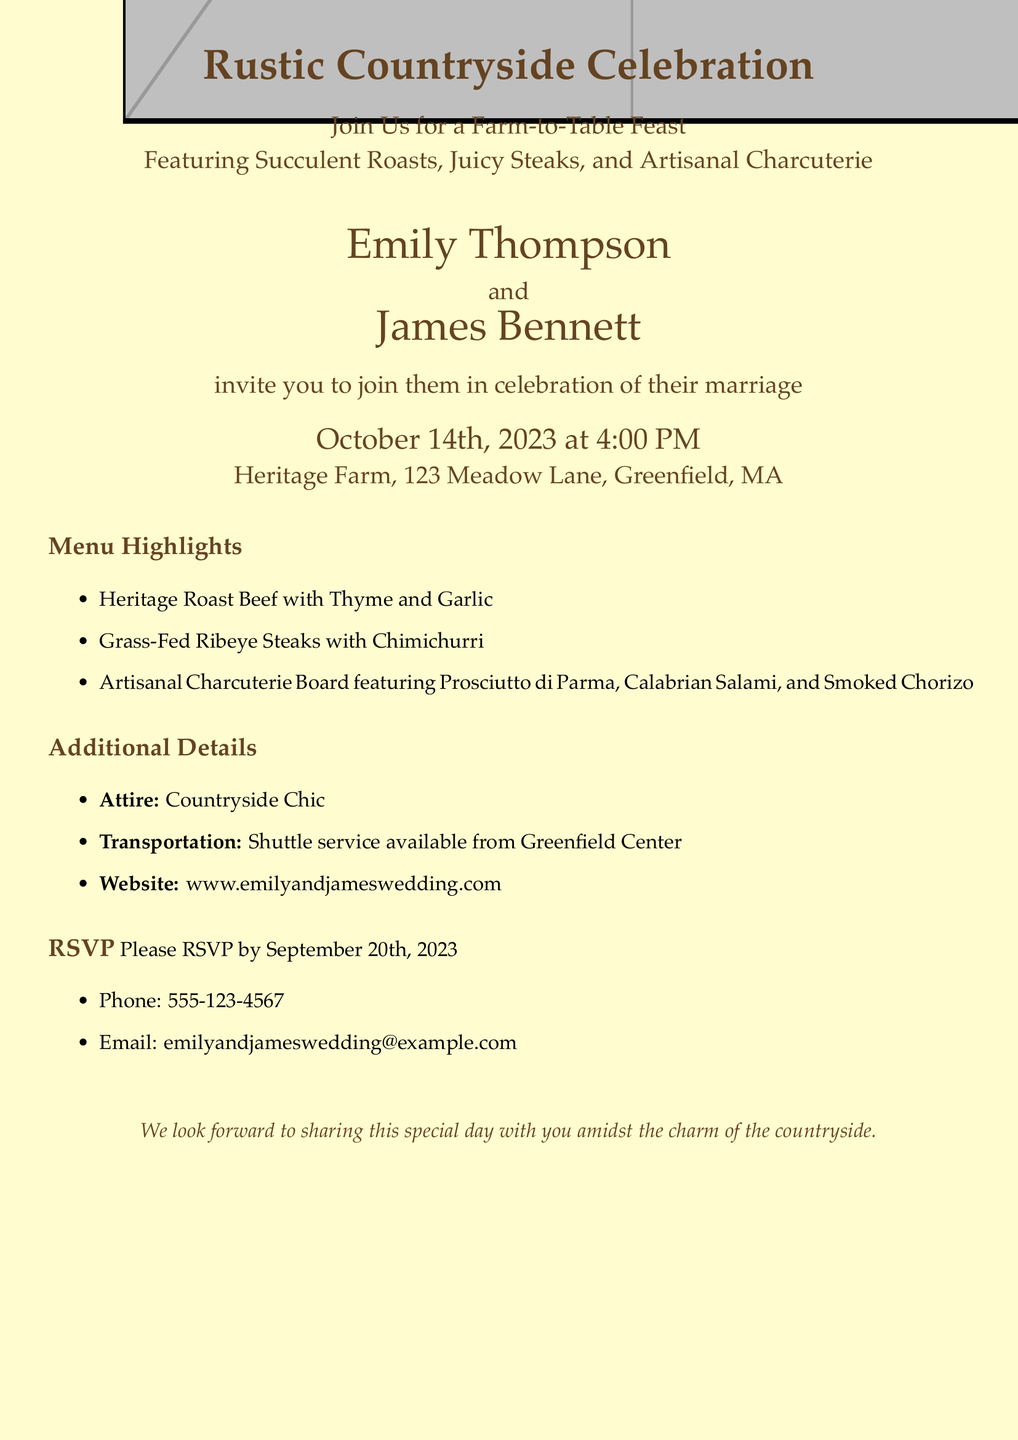What is the date of the wedding? The date of the wedding is explicitly mentioned in the document as October 14th, 2023.
Answer: October 14th, 2023 Who are the couple getting married? The names of the couple getting married are highlighted in the document.
Answer: Emily Thompson and James Bennett What menu item features grass-fed beef? The document lists the menu items, and one of them specifically mentions grass-fed beef.
Answer: Grass-Fed Ribeye Steaks with Chimichurri What time does the celebration start? The starting time of the celebration is provided in the invitation text.
Answer: 4:00 PM What type of attire is recommended? The document specifies the type of attire for the celebration.
Answer: Countryside Chic How many days do guests have to RSVP by? The RSVP deadline is stated in the document, allowing us to calculate the days until the wedding.
Answer: 25 days What is the address of the venue? The venue's address is clearly mentioned in the invitation details.
Answer: Heritage Farm, 123 Meadow Lane, Greenfield, MA Is a shuttle service provided? The document mentions transportation details, indicating whether a shuttle service is available.
Answer: Yes 